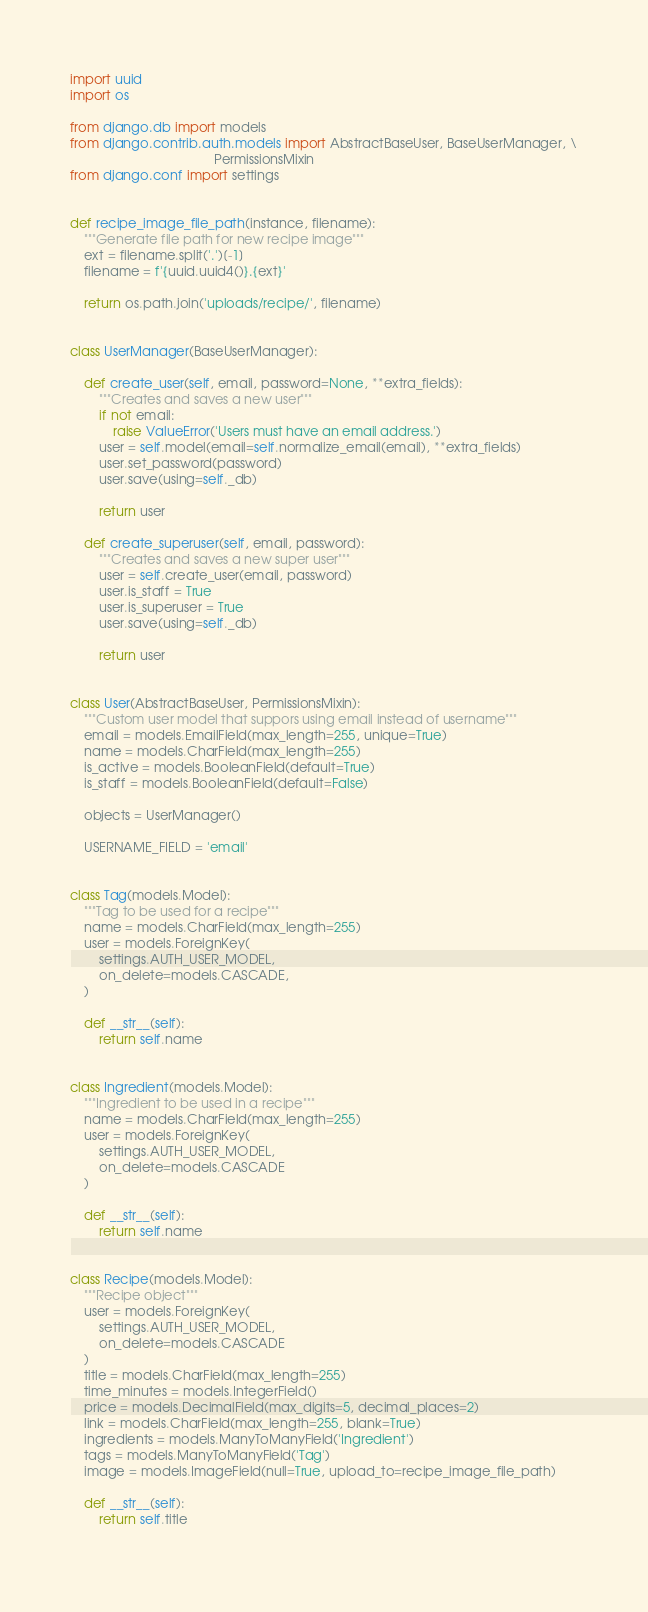<code> <loc_0><loc_0><loc_500><loc_500><_Python_>import uuid
import os

from django.db import models
from django.contrib.auth.models import AbstractBaseUser, BaseUserManager, \
                                        PermissionsMixin
from django.conf import settings


def recipe_image_file_path(instance, filename):
    """Generate file path for new recipe image"""
    ext = filename.split('.')[-1]
    filename = f'{uuid.uuid4()}.{ext}'

    return os.path.join('uploads/recipe/', filename)


class UserManager(BaseUserManager):

    def create_user(self, email, password=None, **extra_fields):
        """Creates and saves a new user"""
        if not email:
            raise ValueError('Users must have an email address.')
        user = self.model(email=self.normalize_email(email), **extra_fields)
        user.set_password(password)
        user.save(using=self._db)

        return user

    def create_superuser(self, email, password):
        """Creates and saves a new super user"""
        user = self.create_user(email, password)
        user.is_staff = True
        user.is_superuser = True
        user.save(using=self._db)

        return user


class User(AbstractBaseUser, PermissionsMixin):
    """Custom user model that suppors using email instead of username"""
    email = models.EmailField(max_length=255, unique=True)
    name = models.CharField(max_length=255)
    is_active = models.BooleanField(default=True)
    is_staff = models.BooleanField(default=False)

    objects = UserManager()

    USERNAME_FIELD = 'email'


class Tag(models.Model):
    """Tag to be used for a recipe"""
    name = models.CharField(max_length=255)
    user = models.ForeignKey(
        settings.AUTH_USER_MODEL,
        on_delete=models.CASCADE,
    )

    def __str__(self):
        return self.name


class Ingredient(models.Model):
    """Ingredient to be used in a recipe"""
    name = models.CharField(max_length=255)
    user = models.ForeignKey(
        settings.AUTH_USER_MODEL,
        on_delete=models.CASCADE
    )

    def __str__(self):
        return self.name


class Recipe(models.Model):
    """Recipe object"""
    user = models.ForeignKey(
        settings.AUTH_USER_MODEL,
        on_delete=models.CASCADE
    )
    title = models.CharField(max_length=255)
    time_minutes = models.IntegerField()
    price = models.DecimalField(max_digits=5, decimal_places=2)
    link = models.CharField(max_length=255, blank=True)
    ingredients = models.ManyToManyField('Ingredient')
    tags = models.ManyToManyField('Tag')
    image = models.ImageField(null=True, upload_to=recipe_image_file_path)

    def __str__(self):
        return self.title
    
</code> 